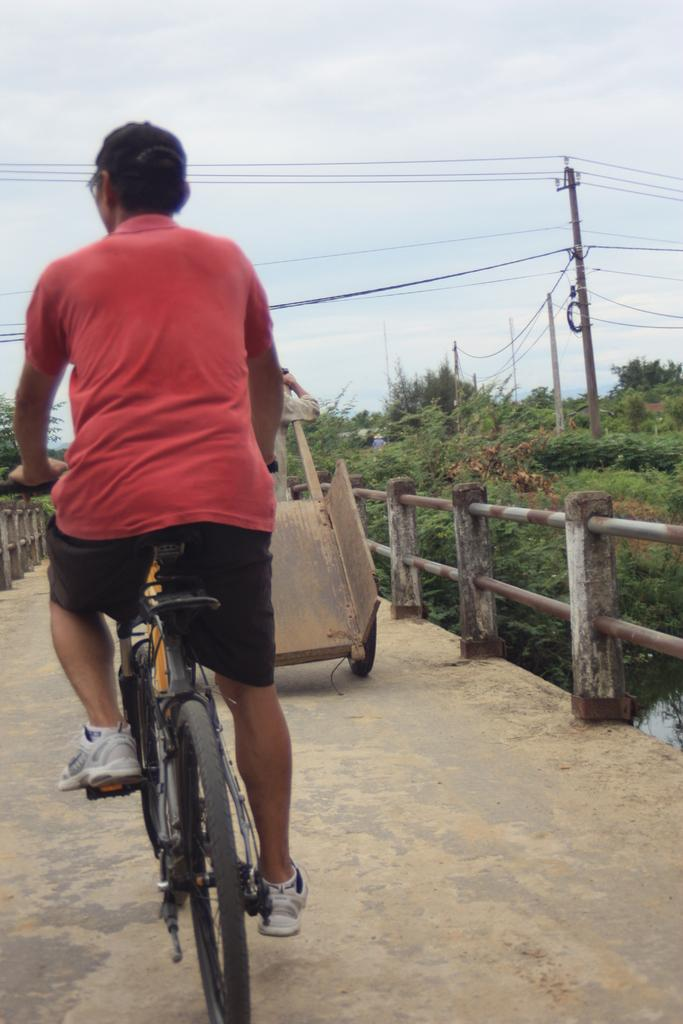What can be seen in the sky in the image? The sky is visible in the image, but no specific details about the sky can be determined from the provided facts. What type of structure is present near the water in the image? There is a current pole and a bridge in the image. What type of vegetation is present in the image? There are trees in the image. What is the man in the image doing? The man is riding a bicycle in the image. What type of brush is the man using to paint the bridge in the image? There is no brush or painting activity present in the image; the man is riding a bicycle. What driving experience does the man have, as seen in the image? The image does not provide any information about the man's driving experience, as he is riding a bicycle, not driving a vehicle. 